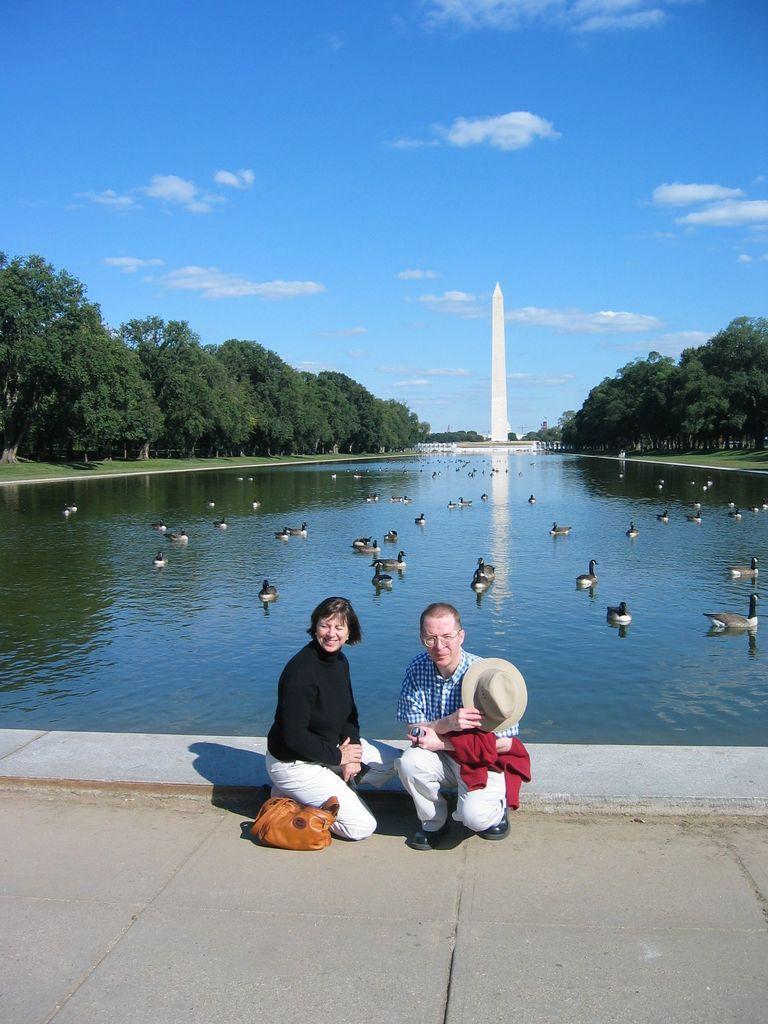How would you summarize this image in a sentence or two? In this image we can see sky with clouds, trees, tower, ducks on the water and persons sitting on the floor. 